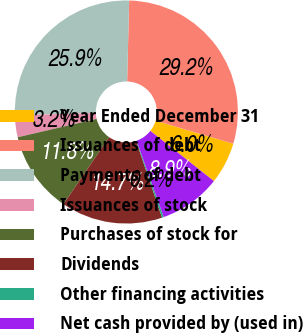Convert chart. <chart><loc_0><loc_0><loc_500><loc_500><pie_chart><fcel>Year Ended December 31<fcel>Issuances of debt<fcel>Payments of debt<fcel>Issuances of stock<fcel>Purchases of stock for<fcel>Dividends<fcel>Other financing activities<fcel>Net cash provided by (used in)<nl><fcel>6.04%<fcel>29.19%<fcel>25.89%<fcel>3.15%<fcel>11.83%<fcel>14.72%<fcel>0.25%<fcel>8.93%<nl></chart> 